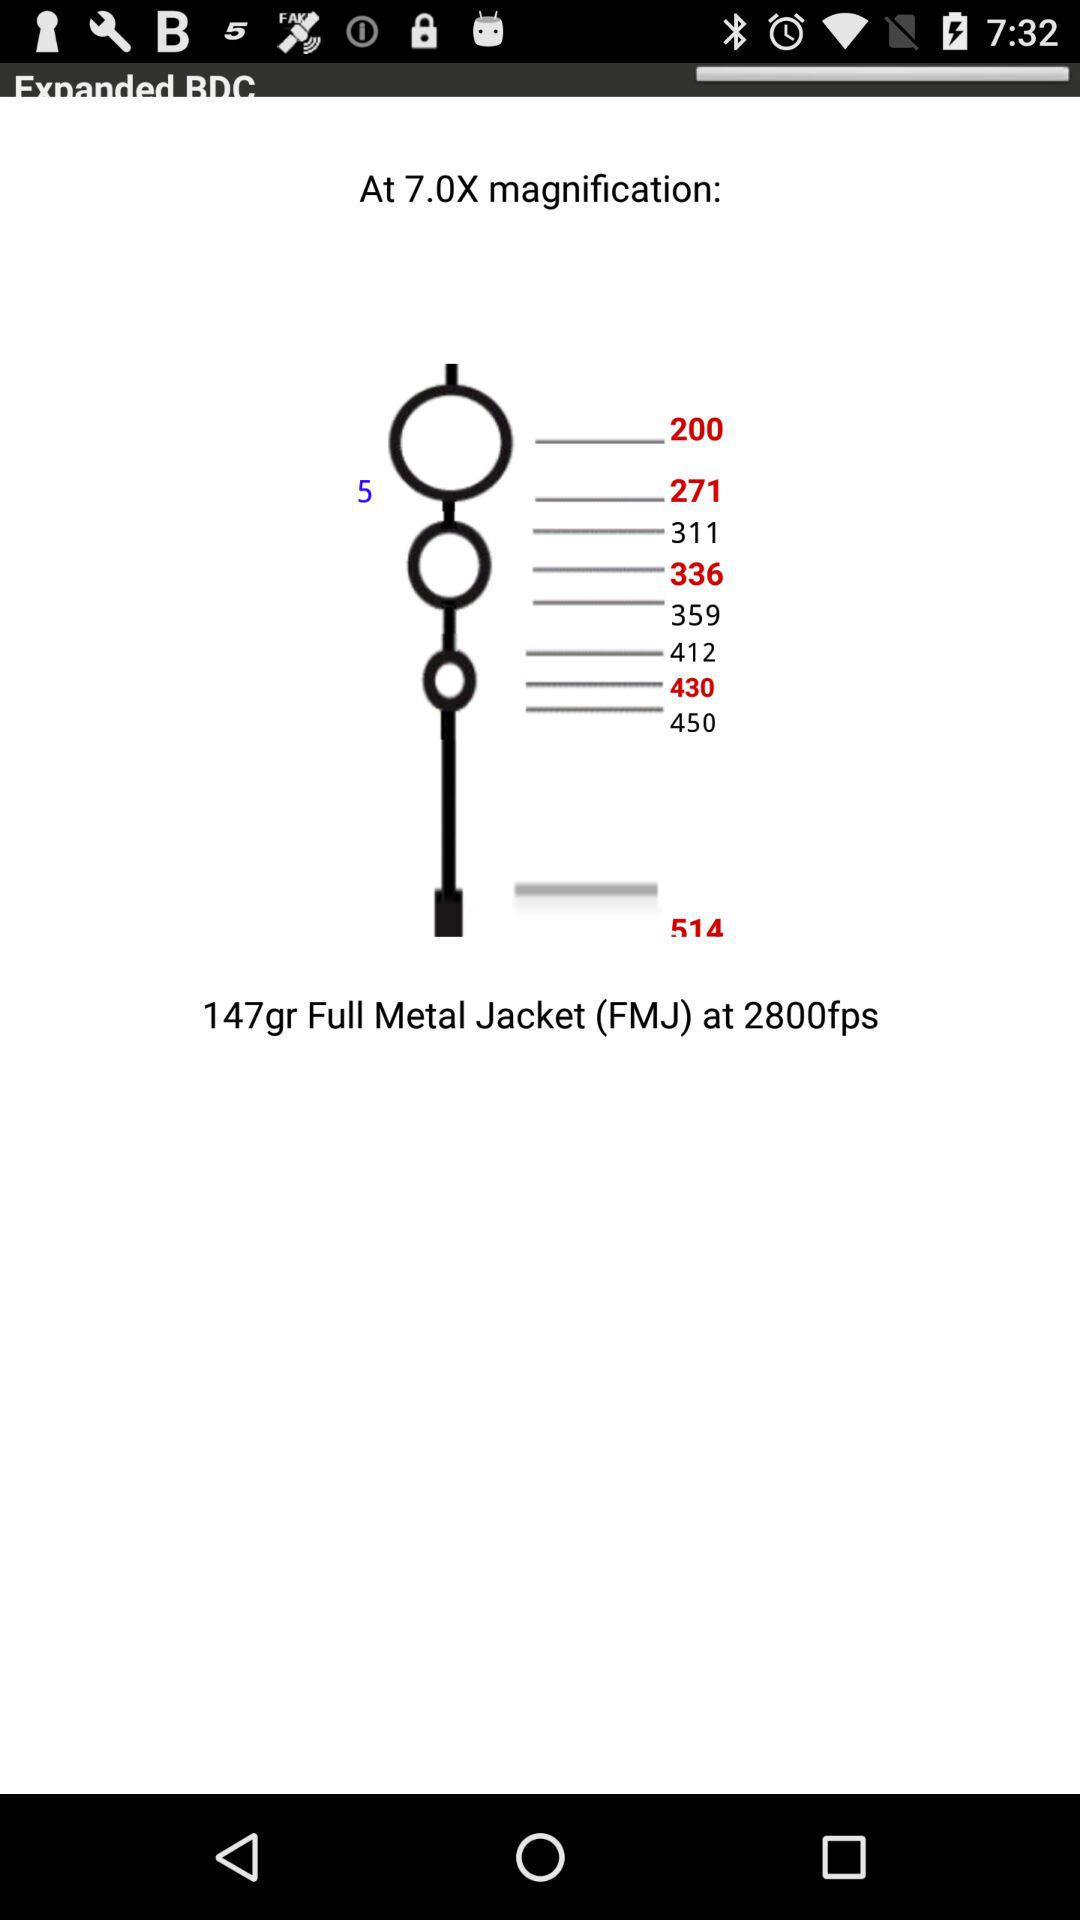What is the maximum magnification?
When the provided information is insufficient, respond with <no answer>. <no answer> 